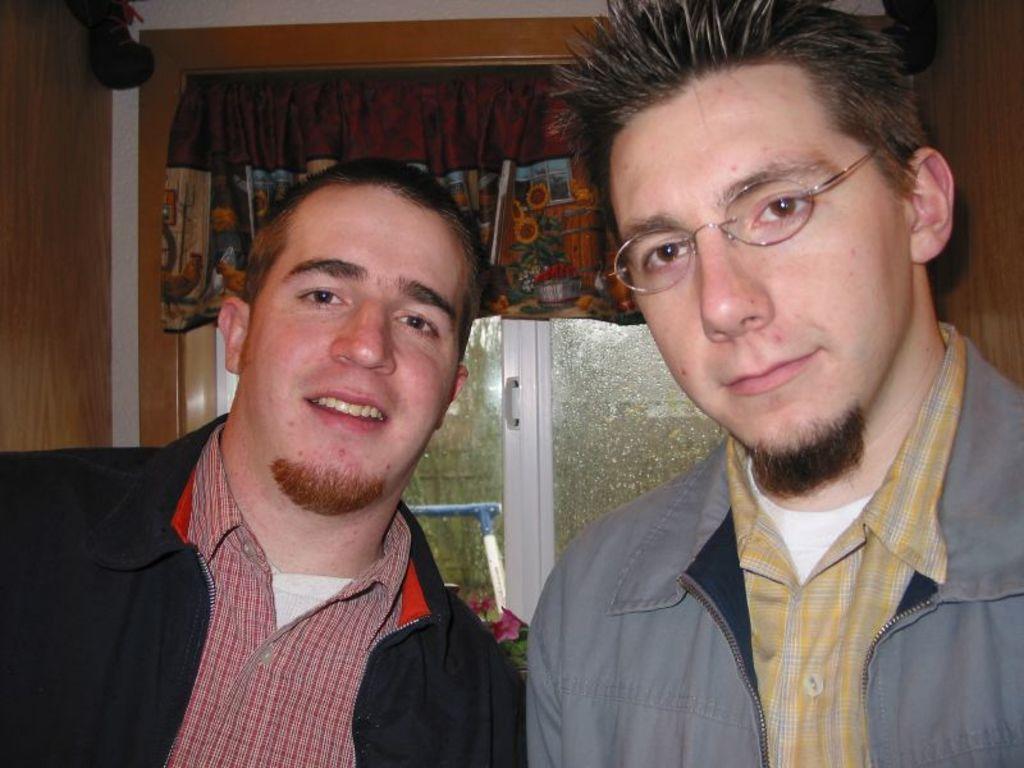How would you summarize this image in a sentence or two? In this picture, we see two men. Both of them are wearing the jackets which are in black and grey color. They are posing for the photo. The man on the right side is wearing the spectacles. Behind them, we see a window and a cloth in brown and yellow color. On the left side, we see a wooden wall. 